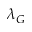<formula> <loc_0><loc_0><loc_500><loc_500>\lambda _ { G }</formula> 